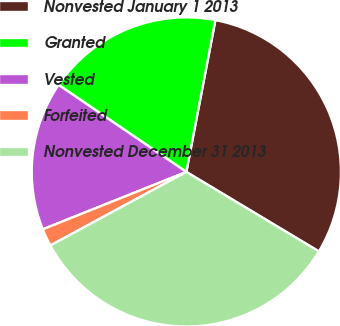Convert chart. <chart><loc_0><loc_0><loc_500><loc_500><pie_chart><fcel>Nonvested January 1 2013<fcel>Granted<fcel>Vested<fcel>Forfeited<fcel>Nonvested December 31 2013<nl><fcel>30.59%<fcel>18.49%<fcel>15.57%<fcel>1.84%<fcel>33.51%<nl></chart> 